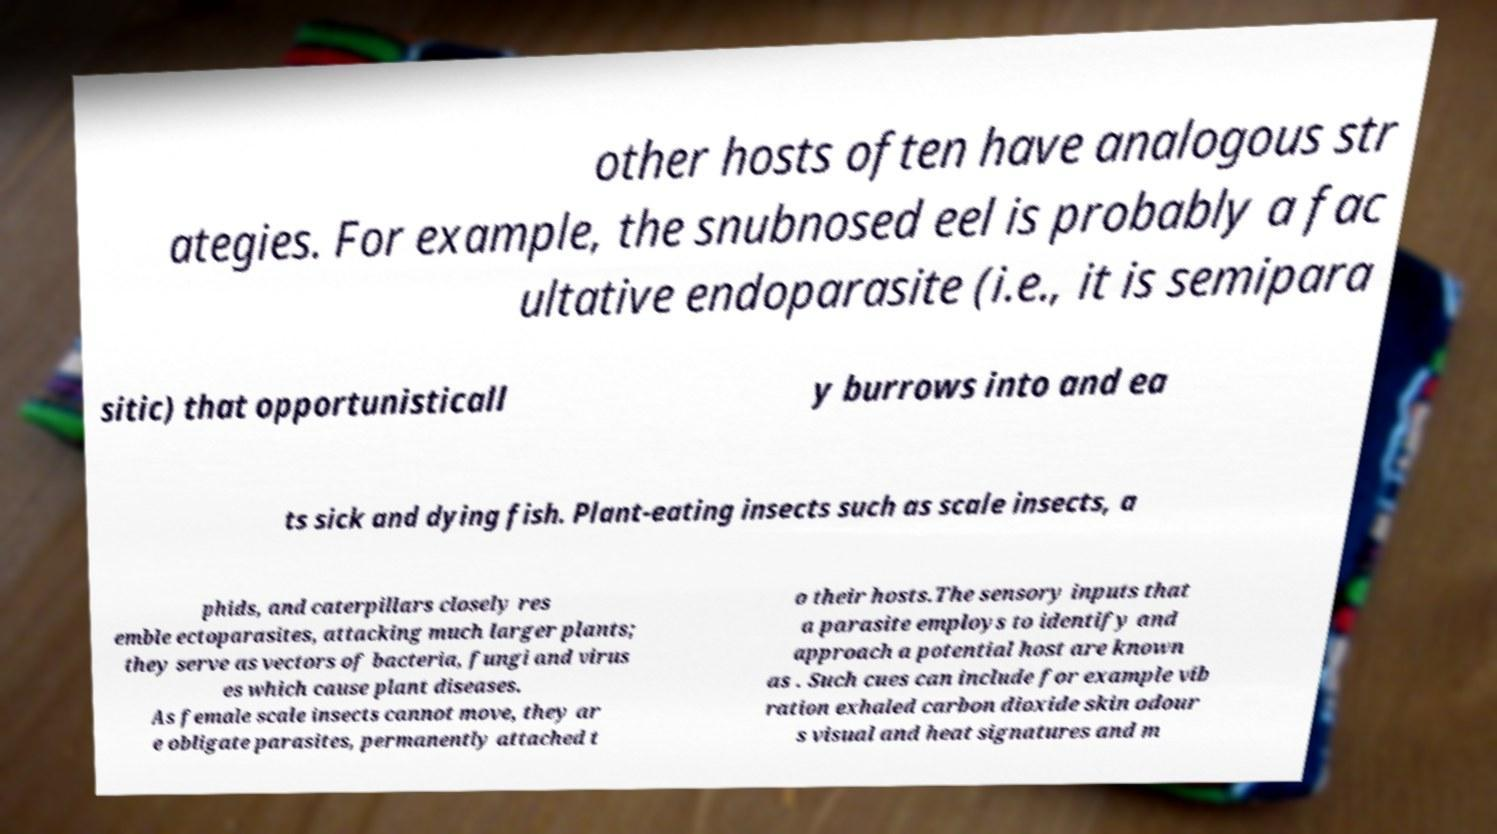Can you accurately transcribe the text from the provided image for me? other hosts often have analogous str ategies. For example, the snubnosed eel is probably a fac ultative endoparasite (i.e., it is semipara sitic) that opportunisticall y burrows into and ea ts sick and dying fish. Plant-eating insects such as scale insects, a phids, and caterpillars closely res emble ectoparasites, attacking much larger plants; they serve as vectors of bacteria, fungi and virus es which cause plant diseases. As female scale insects cannot move, they ar e obligate parasites, permanently attached t o their hosts.The sensory inputs that a parasite employs to identify and approach a potential host are known as . Such cues can include for example vib ration exhaled carbon dioxide skin odour s visual and heat signatures and m 